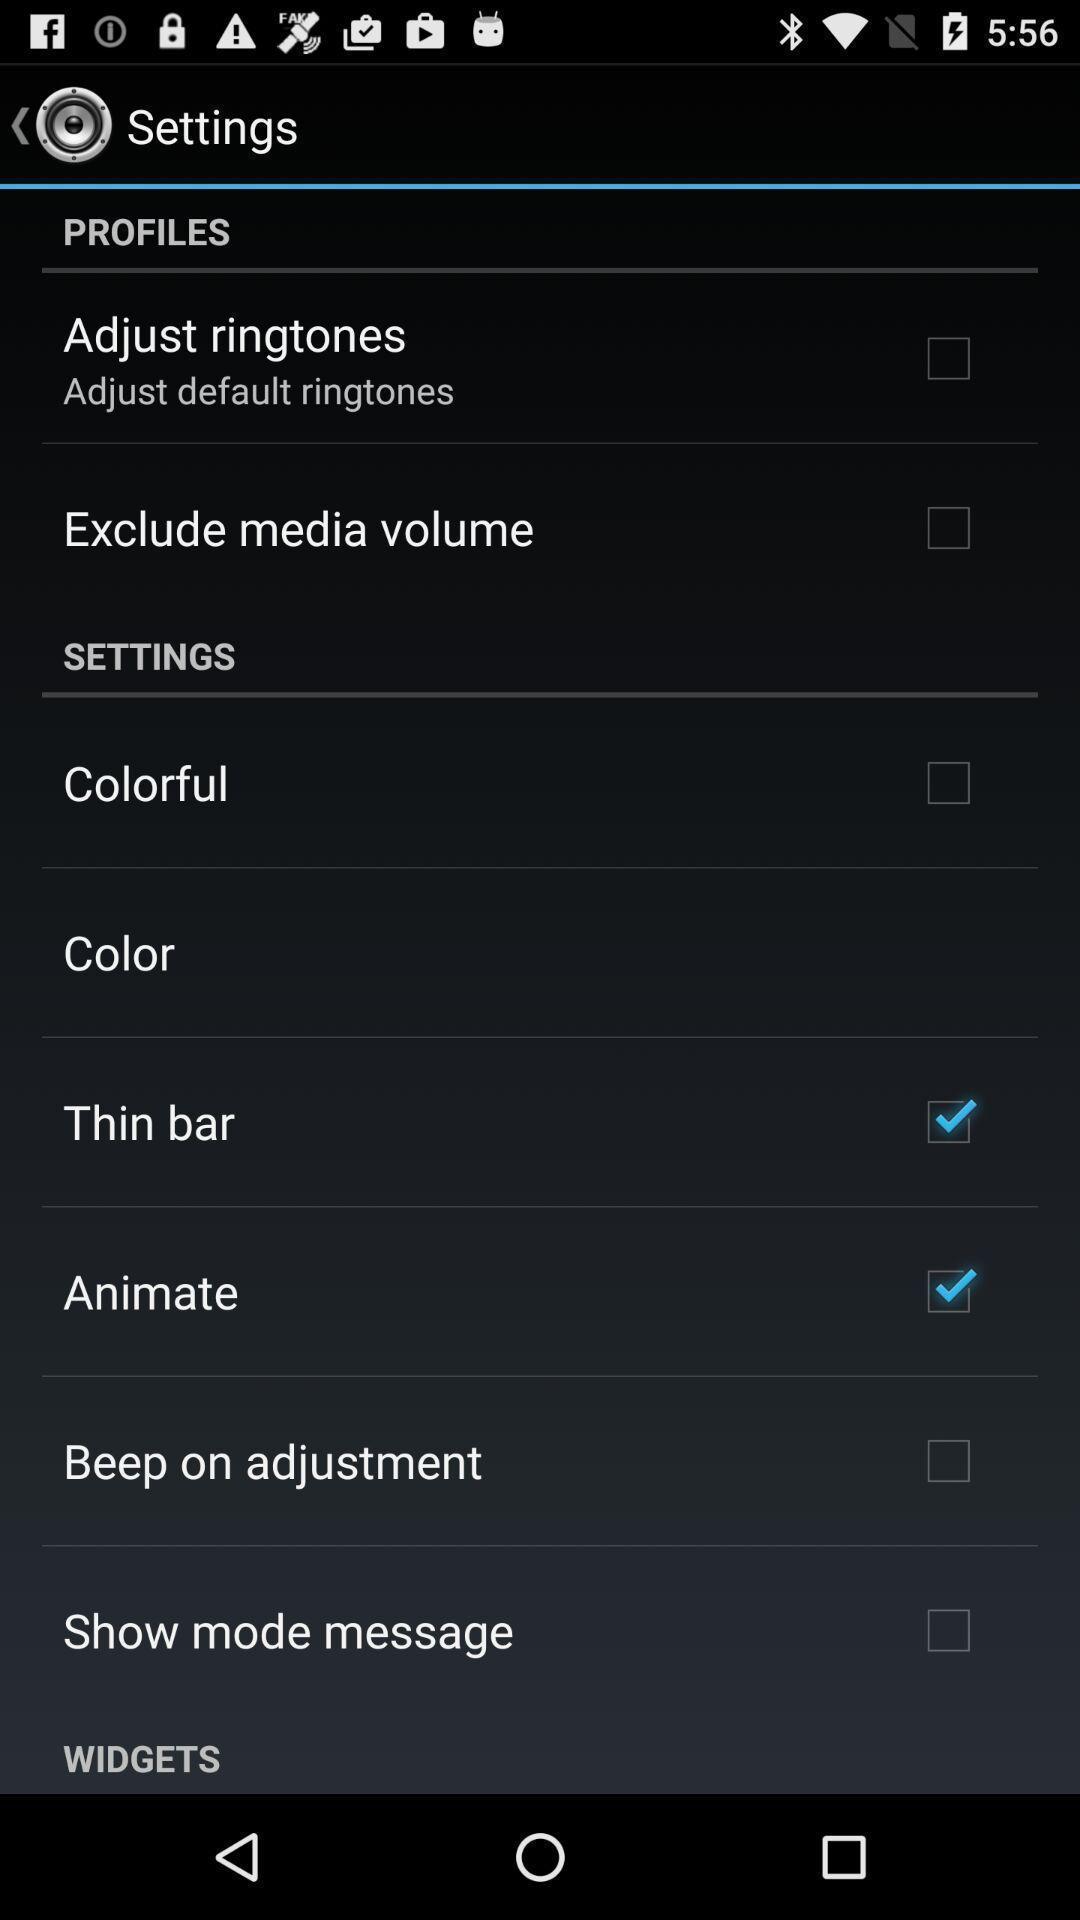Tell me what you see in this picture. Settings page. 